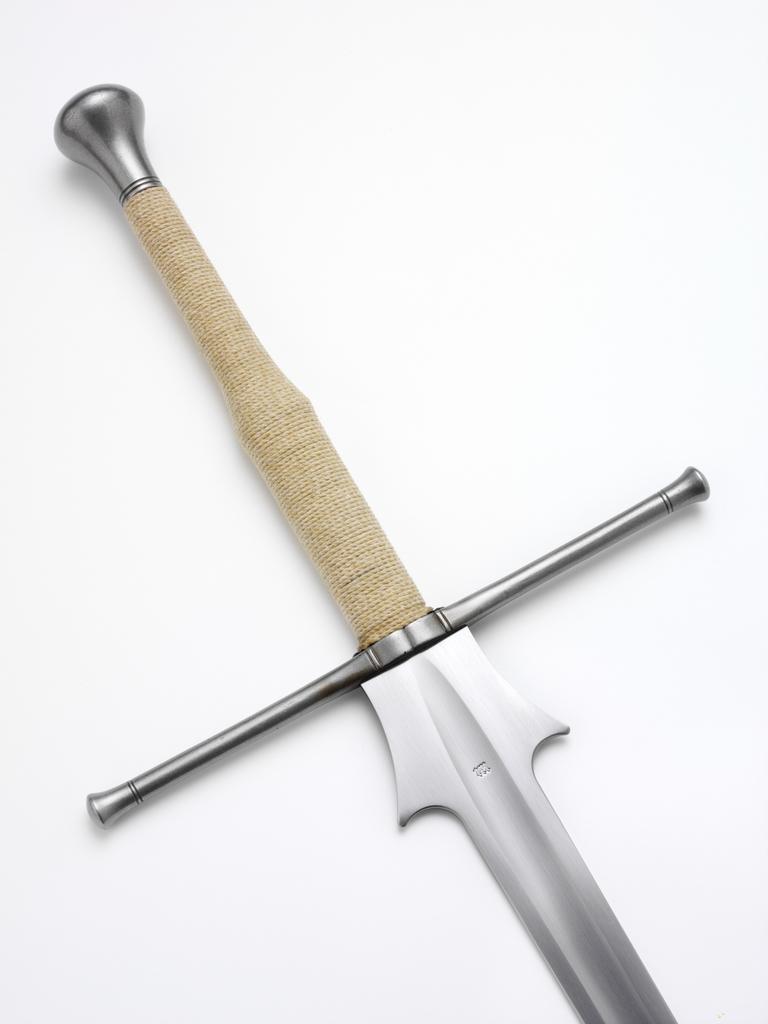Please provide a concise description of this image. In this image we can see a knife on the white color surface. 